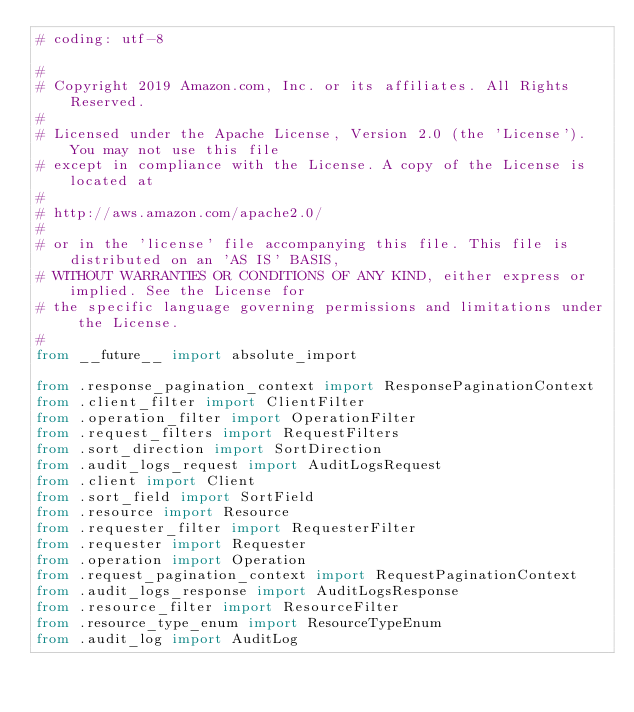<code> <loc_0><loc_0><loc_500><loc_500><_Python_># coding: utf-8

#
# Copyright 2019 Amazon.com, Inc. or its affiliates. All Rights Reserved.
#
# Licensed under the Apache License, Version 2.0 (the 'License'). You may not use this file
# except in compliance with the License. A copy of the License is located at
#
# http://aws.amazon.com/apache2.0/
#
# or in the 'license' file accompanying this file. This file is distributed on an 'AS IS' BASIS,
# WITHOUT WARRANTIES OR CONDITIONS OF ANY KIND, either express or implied. See the License for
# the specific language governing permissions and limitations under the License.
#
from __future__ import absolute_import

from .response_pagination_context import ResponsePaginationContext
from .client_filter import ClientFilter
from .operation_filter import OperationFilter
from .request_filters import RequestFilters
from .sort_direction import SortDirection
from .audit_logs_request import AuditLogsRequest
from .client import Client
from .sort_field import SortField
from .resource import Resource
from .requester_filter import RequesterFilter
from .requester import Requester
from .operation import Operation
from .request_pagination_context import RequestPaginationContext
from .audit_logs_response import AuditLogsResponse
from .resource_filter import ResourceFilter
from .resource_type_enum import ResourceTypeEnum
from .audit_log import AuditLog
</code> 